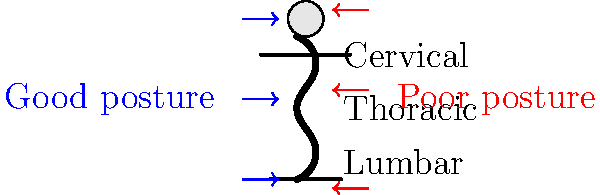As you prepare for independent living, maintaining good posture is crucial for long-term health. Looking at the diagram, which spinal curve is most affected by slouching or hunching forward, and what potential long-term consequence might this have on your ability to perform daily tasks? To answer this question, let's break down the information provided in the diagram and relate it to real-life scenarios:

1. The spine has three main curves:
   a) Cervical (neck region)
   b) Thoracic (upper back)
   c) Lumbar (lower back)

2. Good posture (blue arrows) shows alignment of these curves, while poor posture (red arrows) indicates misalignment.

3. Slouching or hunching forward primarily affects the thoracic curve, causing it to become more pronounced (increased kyphosis).

4. The thoracic curve is in the upper back region, which is crucial for:
   a) Proper breathing (rib cage expansion)
   b) Shoulder and arm movement
   c) Overall spine stability

5. Long-term consequences of poor thoracic posture include:
   a) Decreased lung capacity, leading to reduced endurance
   b) Shoulder and neck pain
   c) Reduced mobility in the upper body
   d) Increased risk of degenerative disc disease

6. These issues can significantly impact daily tasks such as:
   a) Lifting and carrying objects
   b) Reaching for items on high shelves
   c) Performing household chores
   d) Maintaining focus during work or study

Therefore, the thoracic curve is most affected by slouching, and the long-term consequence could be reduced mobility and endurance, affecting your ability to perform daily tasks efficiently in independent living situations.
Answer: Thoracic curve; reduced mobility and endurance for daily tasks. 